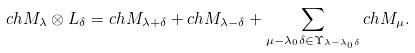<formula> <loc_0><loc_0><loc_500><loc_500>c h M _ { \lambda } \otimes L _ { \delta } = c h M _ { \lambda + \delta } + c h M _ { \lambda - \delta } + \sum _ { \mu - \lambda _ { 0 } \delta \in \Upsilon _ { \lambda - \lambda _ { 0 } \delta } } c h M _ { \mu } .</formula> 